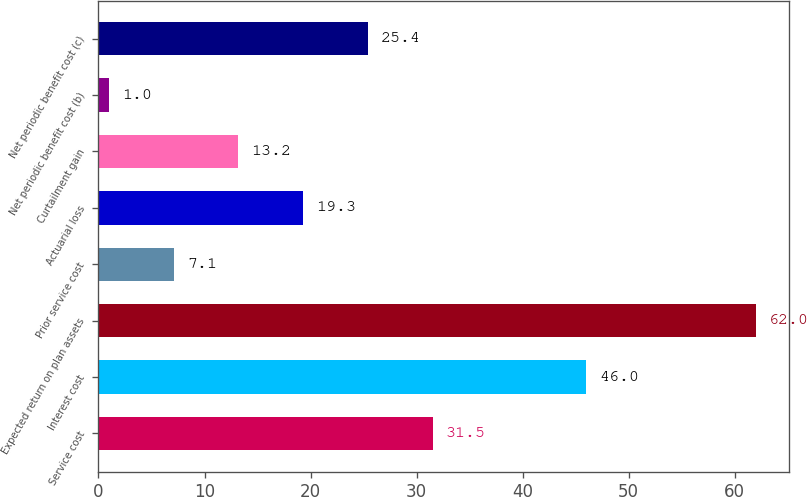Convert chart to OTSL. <chart><loc_0><loc_0><loc_500><loc_500><bar_chart><fcel>Service cost<fcel>Interest cost<fcel>Expected return on plan assets<fcel>Prior service cost<fcel>Actuarial loss<fcel>Curtailment gain<fcel>Net periodic benefit cost (b)<fcel>Net periodic benefit cost (c)<nl><fcel>31.5<fcel>46<fcel>62<fcel>7.1<fcel>19.3<fcel>13.2<fcel>1<fcel>25.4<nl></chart> 